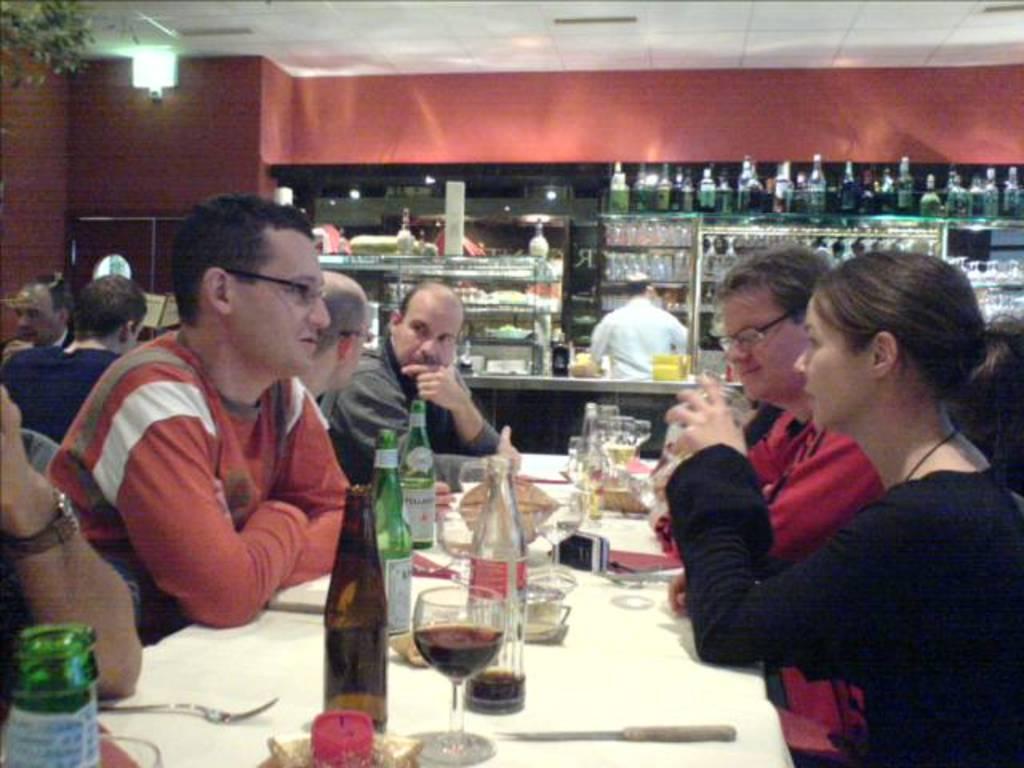Could you give a brief overview of what you see in this image? A group of people are sitting together on the dining table there are beer glasses and wine glasses on this table and there is a light in the left. 